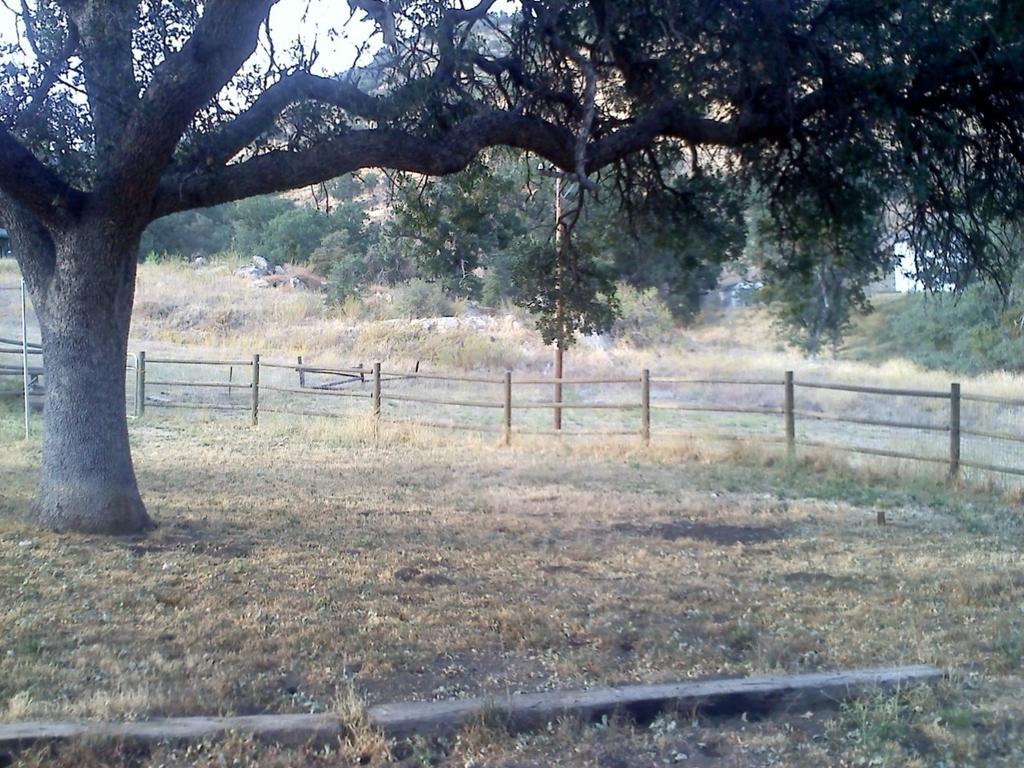Can you describe this image briefly? This is an outside view. On the ground, I can see the grass. On the left side there is a tree. In the middle of the image there is a fencing, behind there is a pole. In the background there are many trees and rocks. 